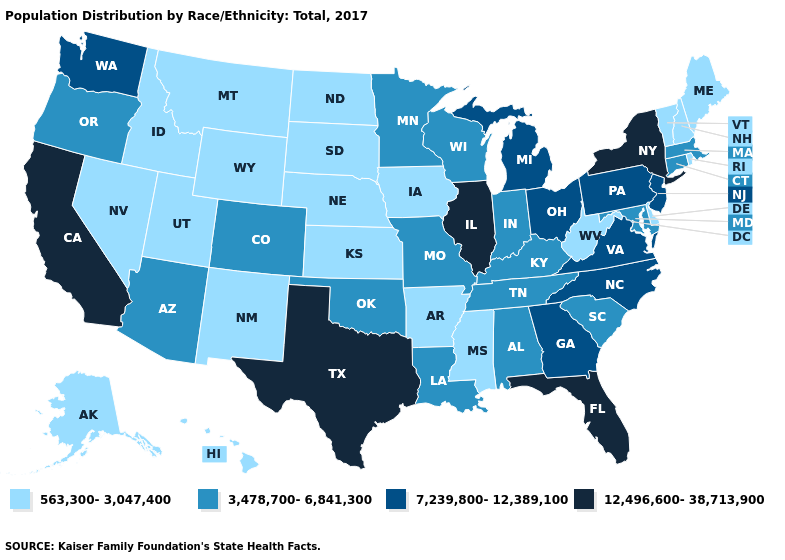Does Alaska have the lowest value in the West?
Keep it brief. Yes. What is the value of Michigan?
Write a very short answer. 7,239,800-12,389,100. Does Colorado have the lowest value in the West?
Give a very brief answer. No. Name the states that have a value in the range 3,478,700-6,841,300?
Write a very short answer. Alabama, Arizona, Colorado, Connecticut, Indiana, Kentucky, Louisiana, Maryland, Massachusetts, Minnesota, Missouri, Oklahoma, Oregon, South Carolina, Tennessee, Wisconsin. What is the highest value in states that border Missouri?
Keep it brief. 12,496,600-38,713,900. Does New York have the highest value in the Northeast?
Write a very short answer. Yes. What is the highest value in the USA?
Answer briefly. 12,496,600-38,713,900. Does Kansas have the same value as Iowa?
Short answer required. Yes. What is the value of Tennessee?
Keep it brief. 3,478,700-6,841,300. Does Pennsylvania have the lowest value in the USA?
Concise answer only. No. How many symbols are there in the legend?
Keep it brief. 4. What is the value of Tennessee?
Keep it brief. 3,478,700-6,841,300. How many symbols are there in the legend?
Answer briefly. 4. What is the value of Texas?
Quick response, please. 12,496,600-38,713,900. What is the value of Massachusetts?
Short answer required. 3,478,700-6,841,300. 